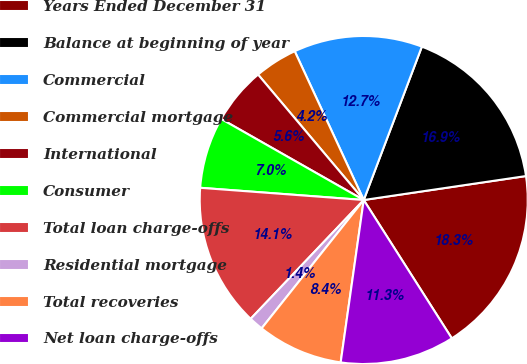Convert chart to OTSL. <chart><loc_0><loc_0><loc_500><loc_500><pie_chart><fcel>Years Ended December 31<fcel>Balance at beginning of year<fcel>Commercial<fcel>Commercial mortgage<fcel>International<fcel>Consumer<fcel>Total loan charge-offs<fcel>Residential mortgage<fcel>Total recoveries<fcel>Net loan charge-offs<nl><fcel>18.31%<fcel>16.9%<fcel>12.68%<fcel>4.23%<fcel>5.63%<fcel>7.04%<fcel>14.08%<fcel>1.41%<fcel>8.45%<fcel>11.27%<nl></chart> 